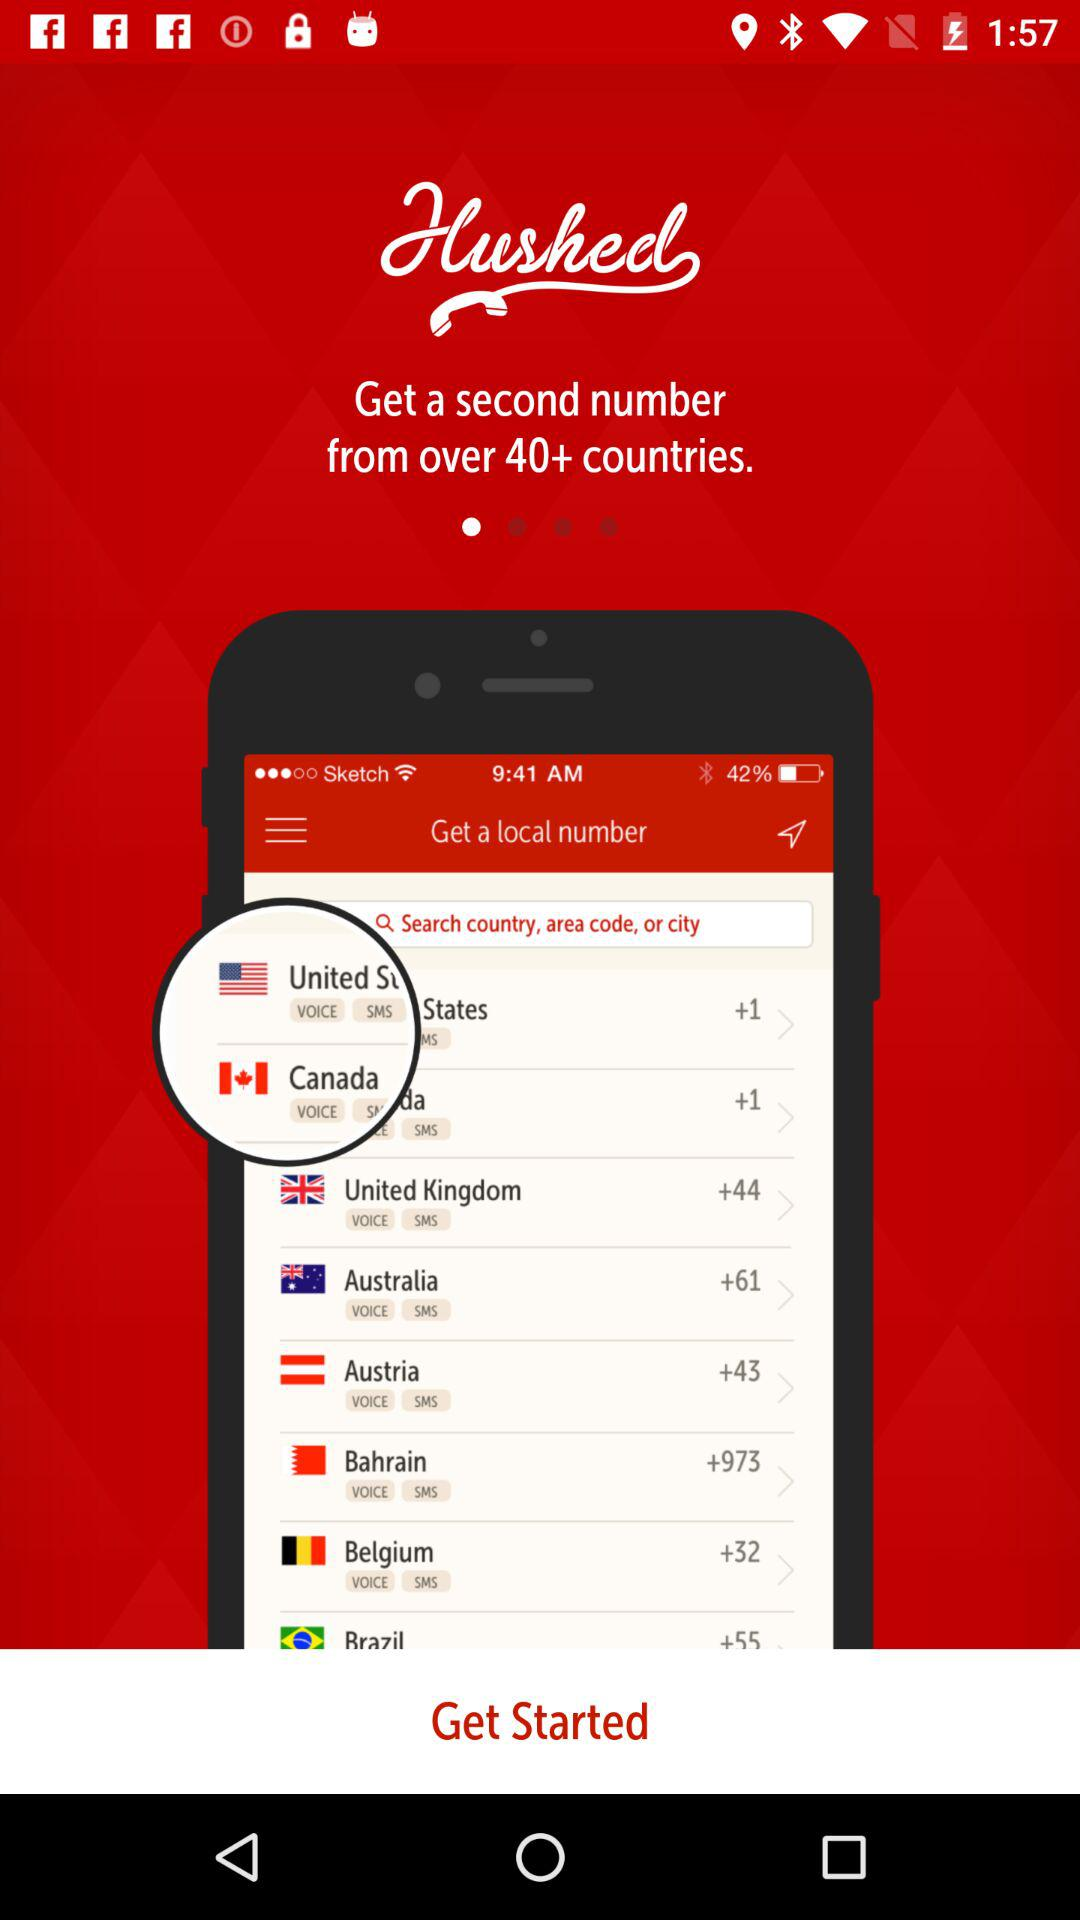What is the country code for Austria? The country code for Austria is +43. 